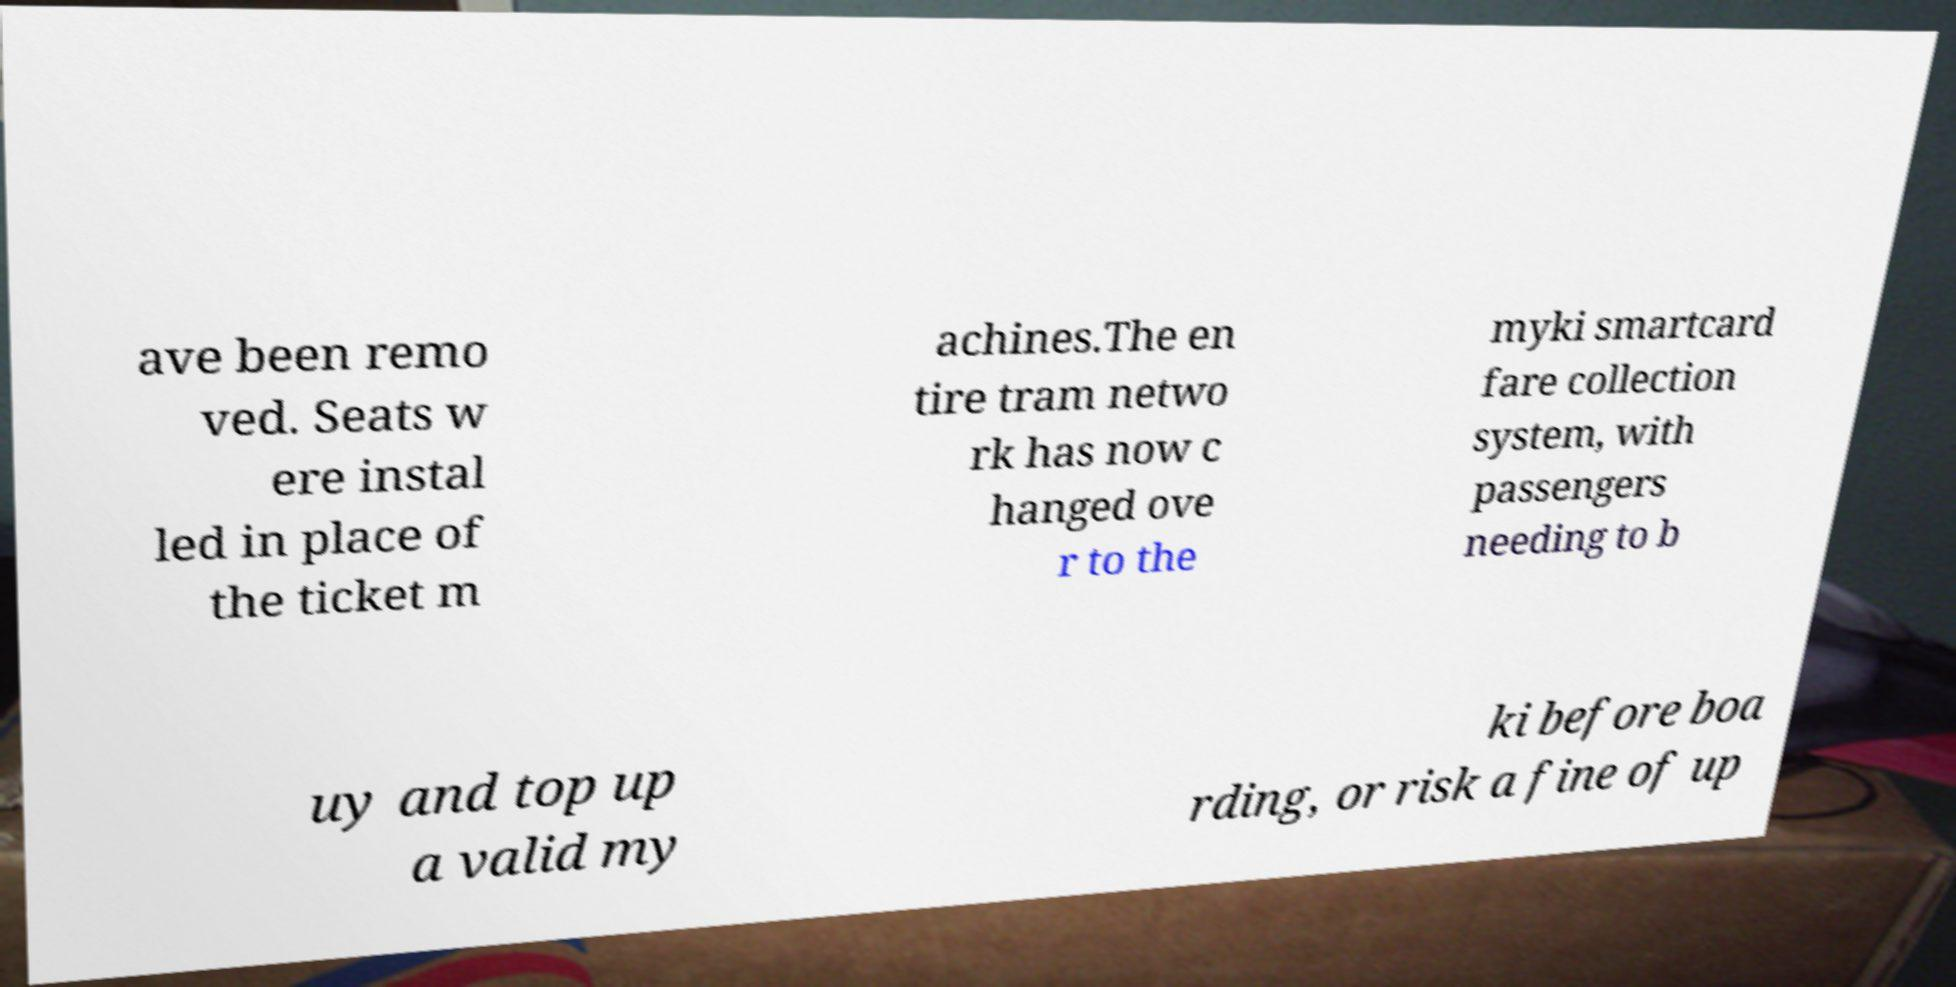There's text embedded in this image that I need extracted. Can you transcribe it verbatim? ave been remo ved. Seats w ere instal led in place of the ticket m achines.The en tire tram netwo rk has now c hanged ove r to the myki smartcard fare collection system, with passengers needing to b uy and top up a valid my ki before boa rding, or risk a fine of up 